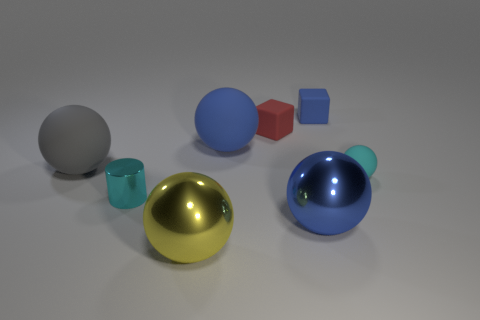Subtract all small spheres. How many spheres are left? 4 Subtract 3 spheres. How many spheres are left? 2 Subtract all blue balls. How many balls are left? 3 Add 3 yellow shiny balls. How many yellow shiny balls are left? 4 Add 2 brown rubber blocks. How many brown rubber blocks exist? 2 Add 1 tiny rubber blocks. How many objects exist? 9 Subtract 0 green cubes. How many objects are left? 8 Subtract all cylinders. How many objects are left? 7 Subtract all purple cylinders. Subtract all purple blocks. How many cylinders are left? 1 Subtract all cyan cylinders. How many brown spheres are left? 0 